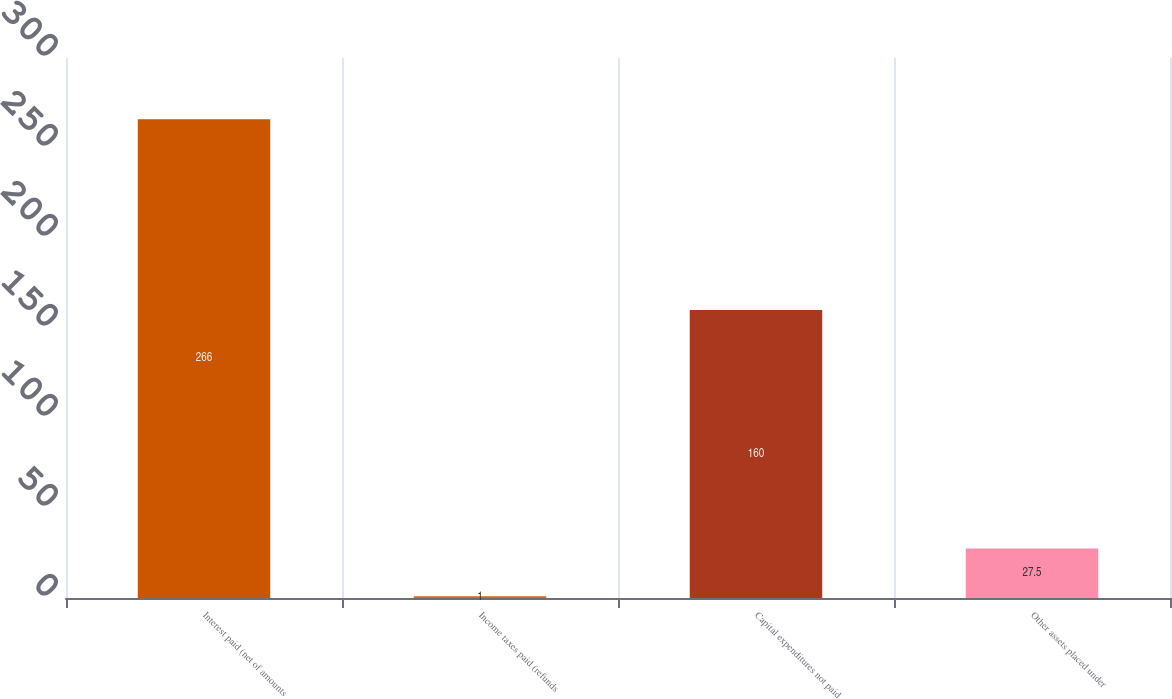Convert chart. <chart><loc_0><loc_0><loc_500><loc_500><bar_chart><fcel>Interest paid (net of amounts<fcel>Income taxes paid (refunds<fcel>Capital expenditures not paid<fcel>Other assets placed under<nl><fcel>266<fcel>1<fcel>160<fcel>27.5<nl></chart> 